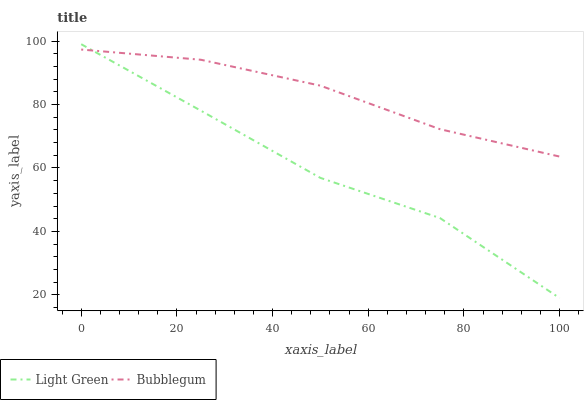Does Light Green have the maximum area under the curve?
Answer yes or no. No. Is Light Green the smoothest?
Answer yes or no. No. 